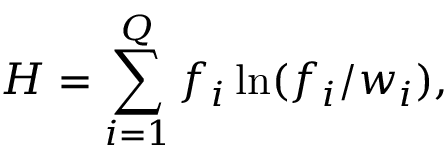Convert formula to latex. <formula><loc_0><loc_0><loc_500><loc_500>H = \sum _ { i = 1 } ^ { Q } f _ { i } \ln ( f _ { i } / w _ { i } ) ,</formula> 